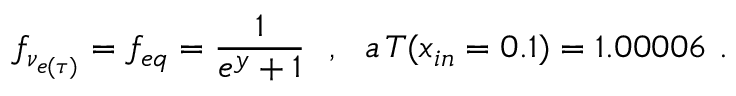<formula> <loc_0><loc_0><loc_500><loc_500>f _ { \nu _ { e ( \tau ) } } = f _ { e q } = \frac { 1 } { e ^ { y } + 1 } , a \, T ( x _ { i n } = 0 . 1 ) = 1 . 0 0 0 0 6 .</formula> 